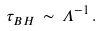Convert formula to latex. <formula><loc_0><loc_0><loc_500><loc_500>\tau _ { B H } \, \sim \, \Lambda ^ { - 1 } \, .</formula> 